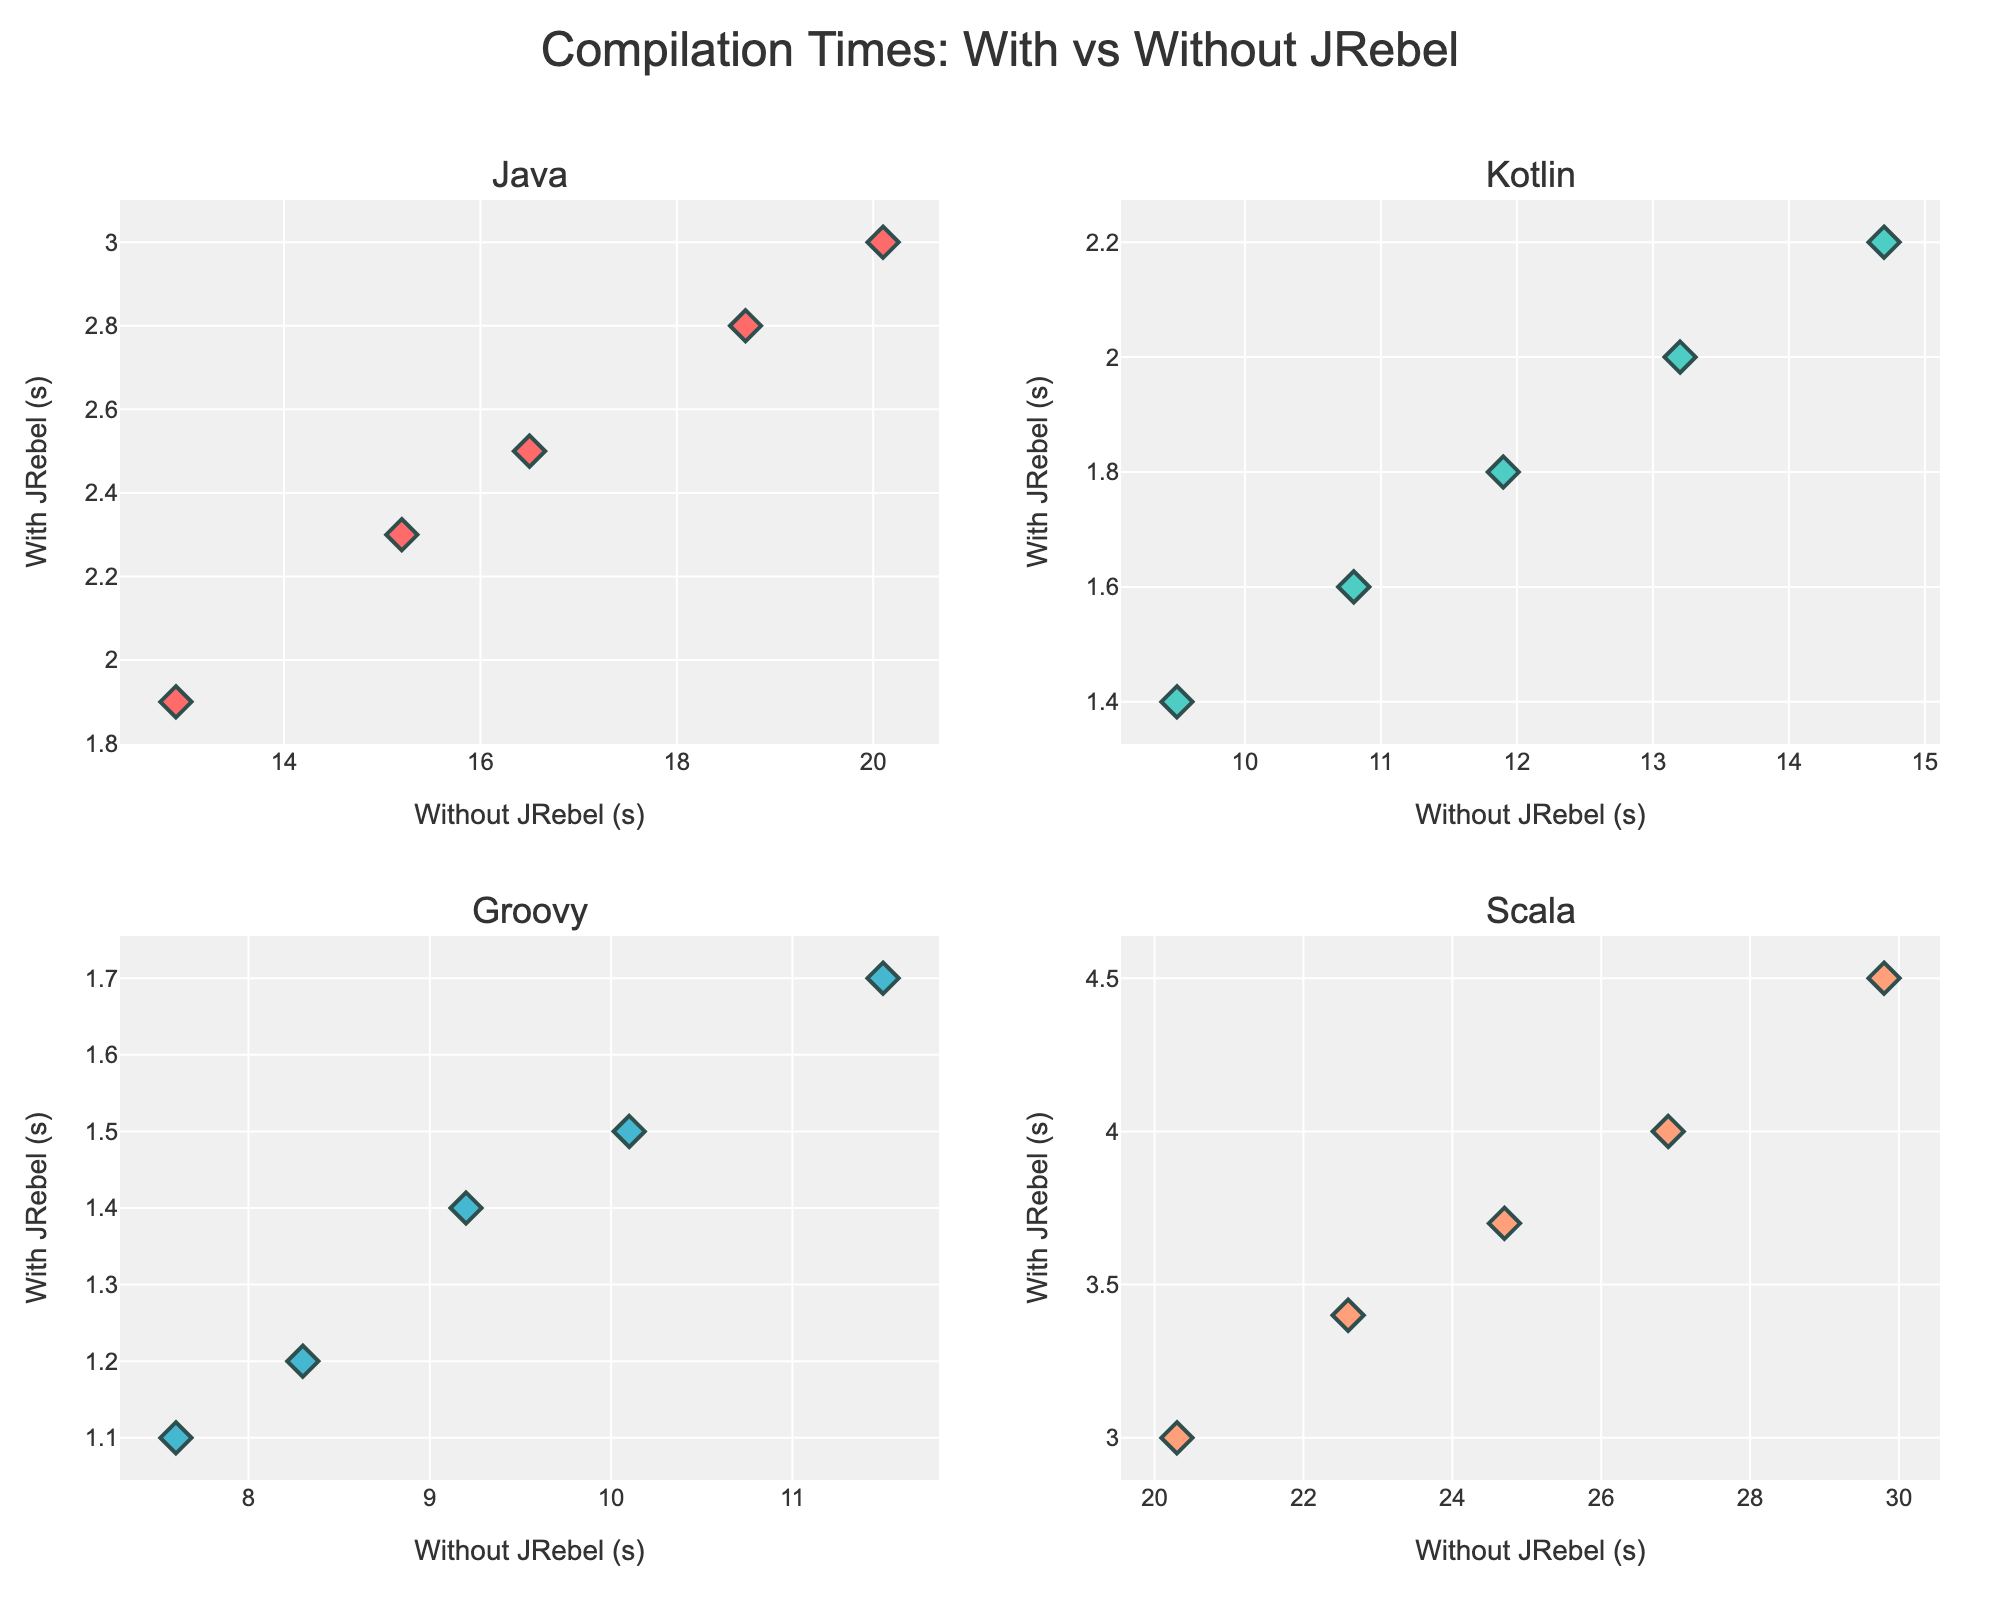What's the title of the figure? The title of the figure is displayed at the top of the plot and usually summarizes the content. Here, it reads "Compilation Times: With vs Without JRebel".
Answer: Compilation Times: With vs Without JRebel How many subplots are there in the figure? The figure is divided into a 2x2 grid, resulting in 4 subplots, one for each programming language: Java, Kotlin, Groovy, and Scala.
Answer: 4 Which language has the highest compilation time without JRebel? To find this, we look at the x-axis range in each subplot and identify the maximum point. Scala's subplot shows a maximum time of 29.8 seconds, which is the highest among all.
Answer: Scala What is the average compilation time with JRebel for Java? Average the given compilation times for Java with JRebel: (2.3 + 2.8 + 1.9 + 3.0 + 2.5) / 5 = 2.5 seconds.
Answer: 2.5 seconds Which language shows the least improvement in compilation time with JRebel? Calculate the difference in average compilation times for each language. Scala shows the smallest relative reduction, indicating the least improvement.
Answer: Scala Is the compilation improvement consistent across all languages when using JRebel? By examining the slopes and clusters of points in each subplot, it's clear that while all show improvement, the degree varies. Consistency in relative terms is not observed.
Answer: No How many data points are there for Kotlin? Count the markers in the Kotlin subplot. There are 5.
Answer: 5 Which language exhibits the widest range of compilation times without JRebel? By looking at the x-axis spread in each subplot, Scala shows the widest range (from 20.3 to 29.8 seconds).
Answer: Scala Does Groovy have any compilation times without JRebel that are higher than 12 seconds? Observing the Groovy subplot, all points are below 12 seconds.
Answer: No 